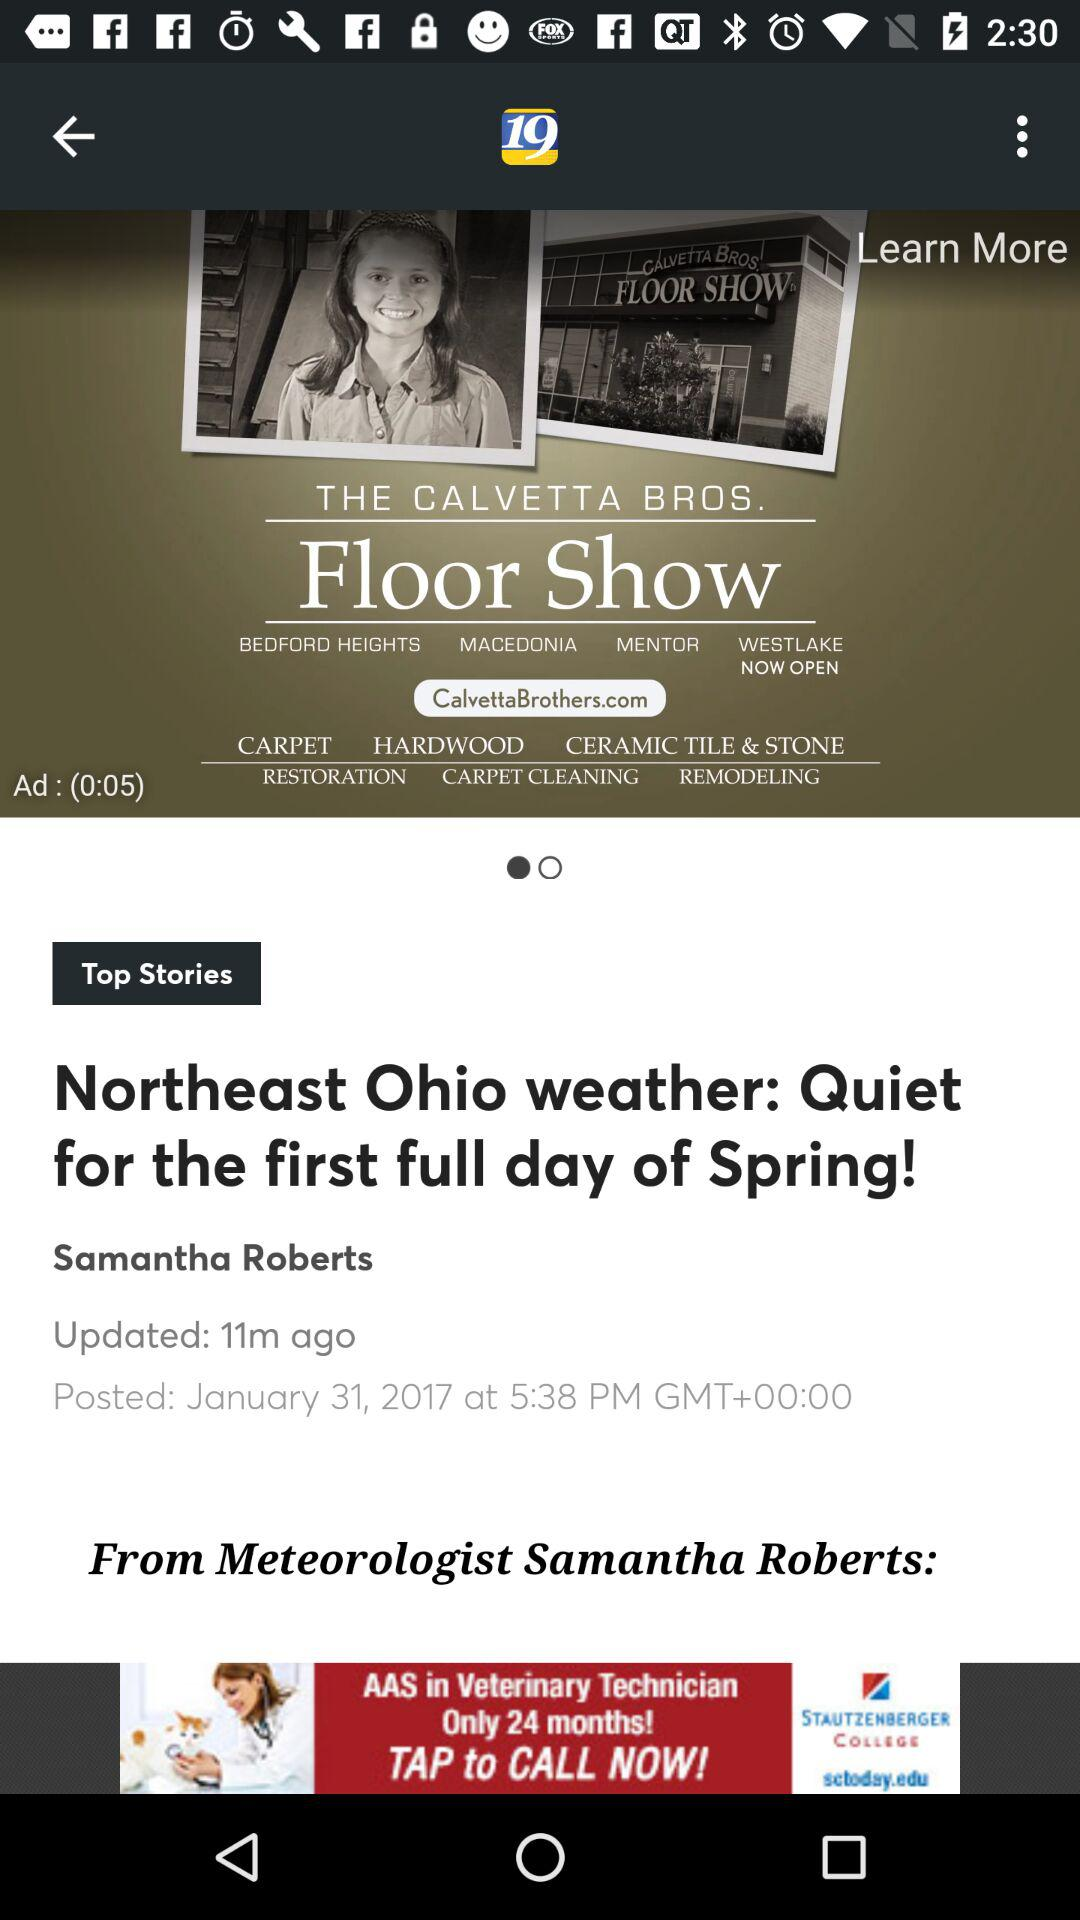When was the article updated? The article was updated 11 minutes ago. 